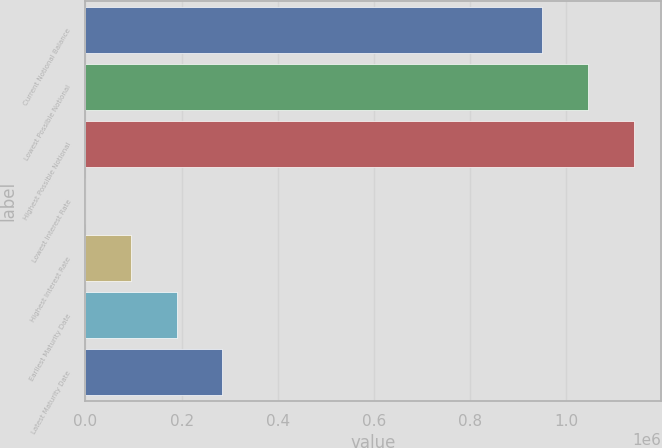<chart> <loc_0><loc_0><loc_500><loc_500><bar_chart><fcel>Current Notional Balance<fcel>Lowest Possible Notional<fcel>Highest Possible Notional<fcel>Lowest Interest Rate<fcel>Highest Interest Rate<fcel>Earliest Maturity Date<fcel>Latest Maturity Date<nl><fcel>950000<fcel>1.045e+06<fcel>1.14e+06<fcel>3.48<fcel>95003.1<fcel>190003<fcel>285002<nl></chart> 